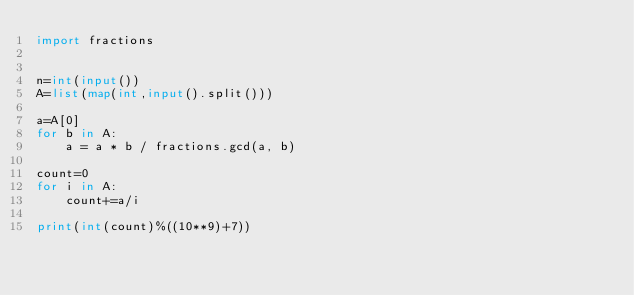Convert code to text. <code><loc_0><loc_0><loc_500><loc_500><_Python_>import fractions


n=int(input())
A=list(map(int,input().split()))

a=A[0]
for b in A:
    a = a * b / fractions.gcd(a, b)

count=0
for i in A:
    count+=a/i

print(int(count)%((10**9)+7))</code> 